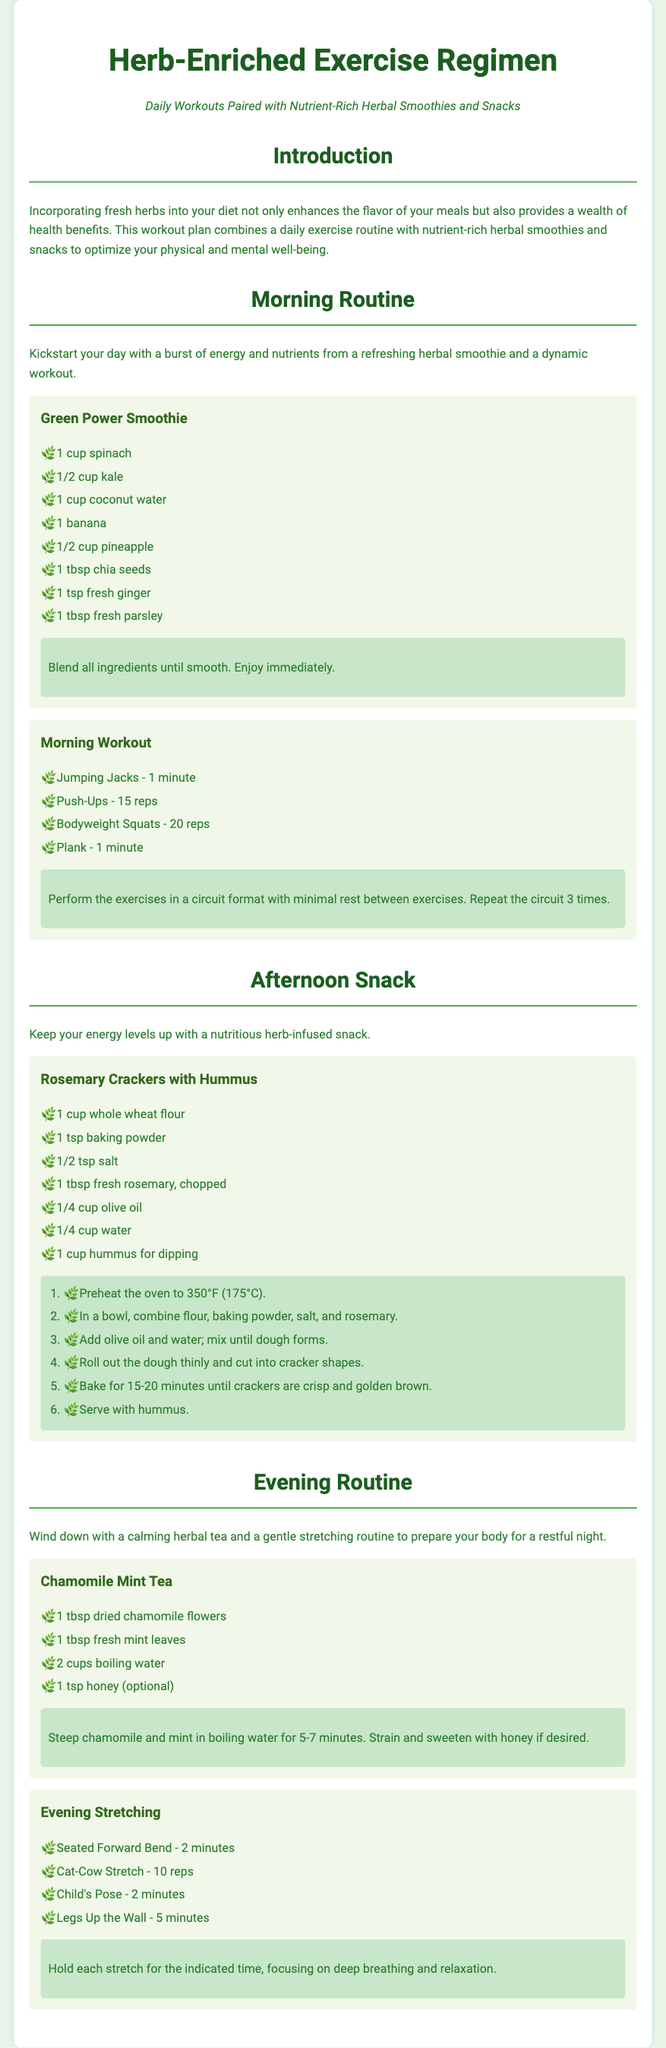What is the name of the morning smoothie? The morning smoothie is titled "Green Power Smoothie" in the document.
Answer: Green Power Smoothie How many reps of push-ups are included in the morning workout? The morning workout specifies 15 reps of push-ups.
Answer: 15 reps What is the main ingredient in the Rosemary Crackers recipe? The main ingredient mentioned for the Rosemary Crackers is whole wheat flour.
Answer: Whole wheat flour How long should the Chamomile Mint Tea be steeped? The document states to steep for 5-7 minutes.
Answer: 5-7 minutes What is the duration for the Seated Forward Bend stretch? The duration for the Seated Forward Bend stretch is specified as 2 minutes in the document.
Answer: 2 minutes What type of tea is suggested for the evening routine? The evening routine suggests Chamomile Mint Tea.
Answer: Chamomile Mint Tea Which herb is emphasized in the afternoon snack? The afternoon snack emphasizes fresh rosemary.
Answer: Fresh rosemary How many exercises are included in the morning workout circuit? The morning workout contains 4 exercises listed in the circuit format.
Answer: 4 exercises 